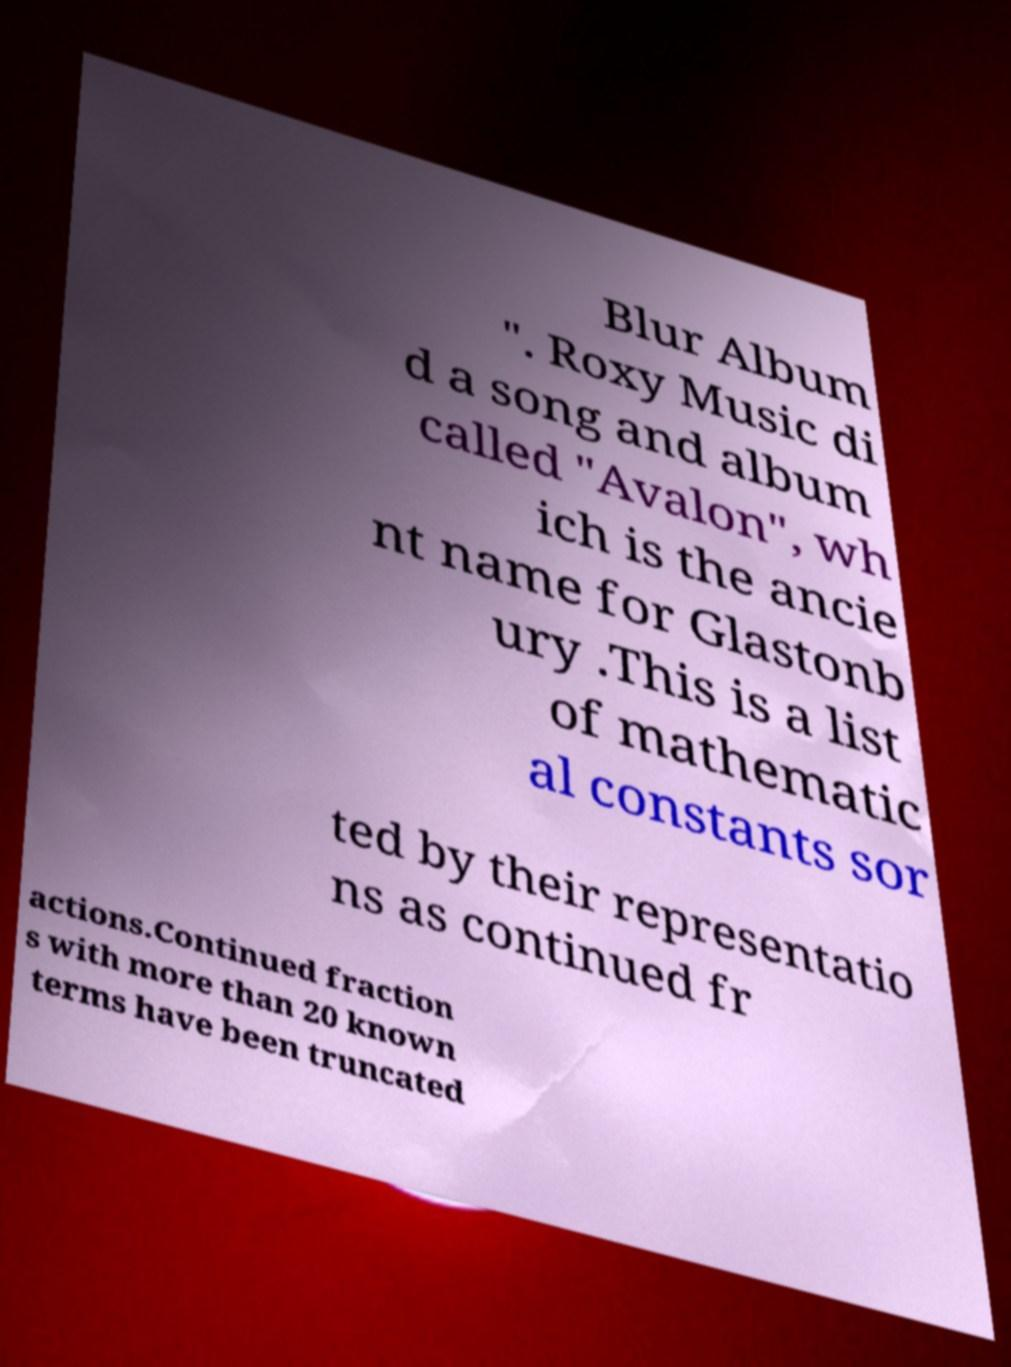Can you read and provide the text displayed in the image?This photo seems to have some interesting text. Can you extract and type it out for me? Blur Album ". Roxy Music di d a song and album called "Avalon", wh ich is the ancie nt name for Glastonb ury .This is a list of mathematic al constants sor ted by their representatio ns as continued fr actions.Continued fraction s with more than 20 known terms have been truncated 